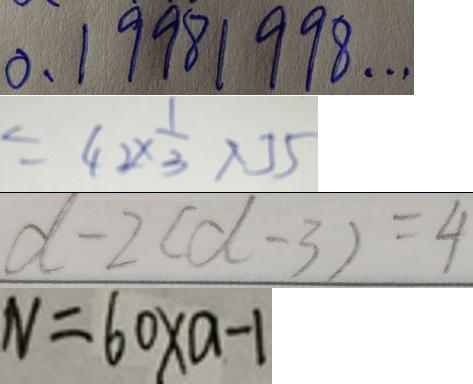<formula> <loc_0><loc_0><loc_500><loc_500>0 . 1 9 9 8 1 9 9 8 \cdots 
 = 4 2 \times \frac { 1 } { 3 } \times 5 
 d - 2 ( d - 3 ) = 4 
 N = 6 0 \times a - 1</formula> 